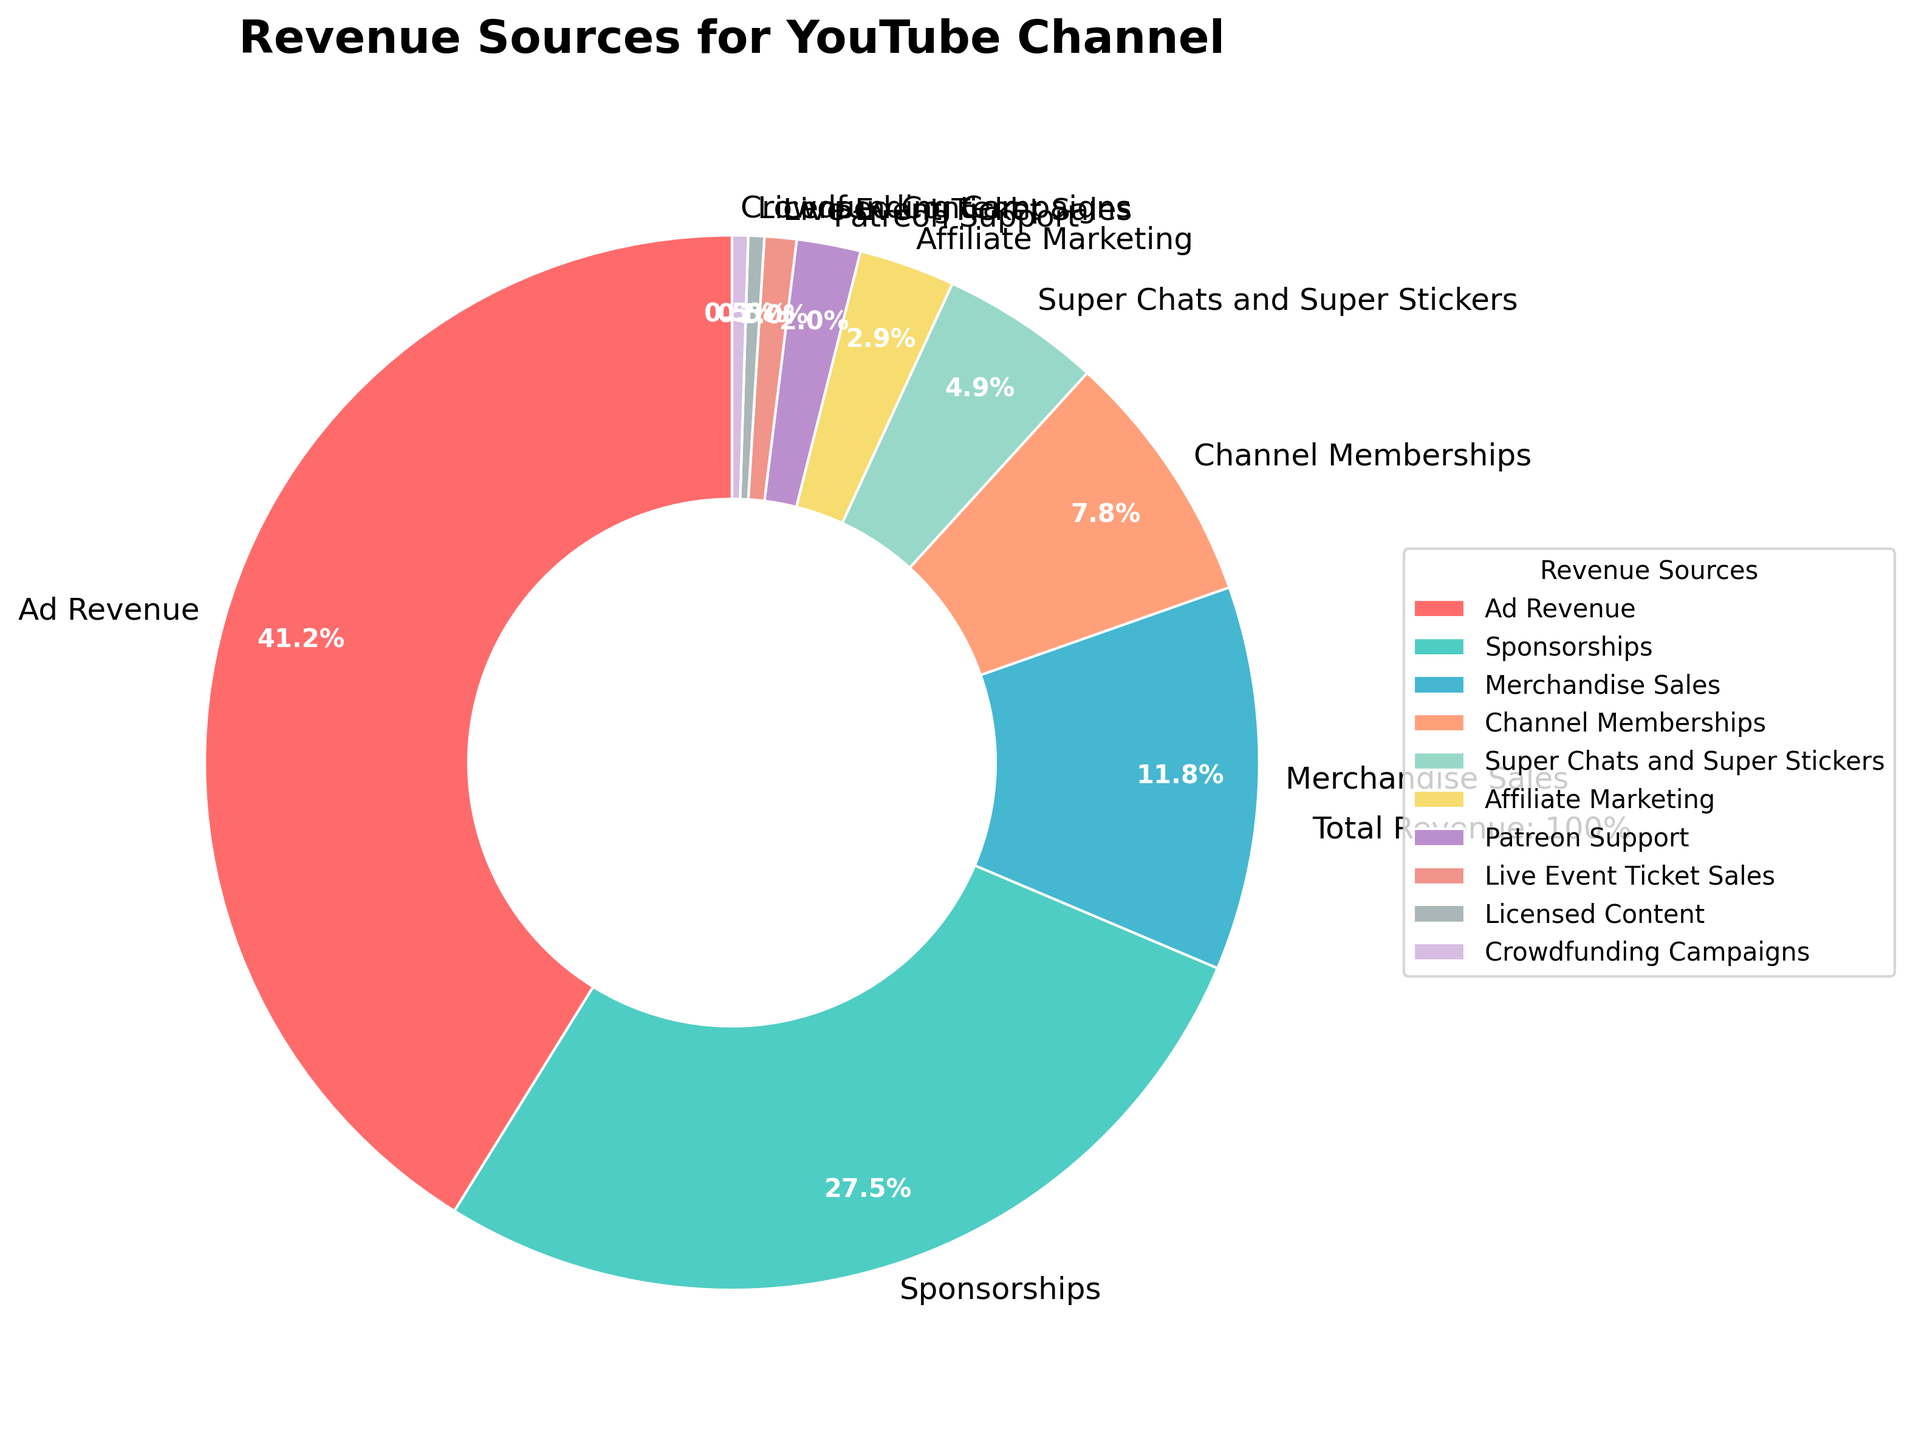Which revenue source contributes the most to the total revenue? By examining the pie chart, we can observe that the segment representing Ad Revenue is the largest. This indicates that Ad Revenue contributes the most to the total revenue of the YouTube channel.
Answer: Ad Revenue What percentage of the total revenue comes from Sponsorships and Merchandise Sales combined? From the pie chart, Sponsorships contribute 28% and Merchandise Sales contribute 12%. Adding these together, we get 28% + 12% = 40%.
Answer: 40% How does the revenue from Channel Memberships compare to the revenue from Super Chats and Super Stickers? The pie chart shows that Channel Memberships account for 8% of the revenue, whereas Super Chats and Super Stickers account for 5%. Therefore, Channel Memberships generate more revenue than Super Chats and Super Stickers.
Answer: Channel Memberships generate more Which revenue source contributes the least to the total revenue? Looking at the pie chart, both Licensed Content and Crowdfunding Campaigns appear to be the smallest segments with 0.5% each. Thus, they contribute the least to the total revenue.
Answer: Licensed Content and Crowdfunding Campaigns What is the combined percentage of revenue generated by Affiliate Marketing, Patreon Support, and Live Event Ticket Sales? According to the pie chart, Affiliate Marketing accounts for 3%, Patreon Support for 2%, and Live Event Ticket Sales for 1%. Adding these together results in 3% + 2% + 1% = 6%.
Answer: 6% What percentage of revenue is generated from non-advertising sources? Summing up the percentages of all revenue sources except Ad Revenue (42%), we have: Sponsorships (28%) + Merchandise Sales (12%) + Channel Memberships (8%) + Super Chats and Super Stickers (5%) + Affiliate Marketing (3%) + Patreon Support (2%) + Live Event Ticket Sales (1%) + Licensed Content (0.5%) + Crowdfunding Campaigns (0.5%) = 60%.
Answer: 60% If Ad Revenue and Sponsorships are combined, what percentage of the total revenue do they account for? Ad Revenue contributes 42% and Sponsorships contribute 28%. Adding these together, we get 42% + 28% = 70%.
Answer: 70% What is the visual color of the segment representing Merchandise Sales in the pie chart? Referring to the visual attributes in the pie chart legend, the segment for Merchandise Sales is represented in a light orange color.
Answer: Light orange How does Merchandise Sales revenue compare to Channel Memberships revenue in terms of percentage? The pie chart indicates that Merchandise Sales account for 12% and Channel Memberships account for 8%. Therefore, Merchandise Sales generate 4% more revenue than Channel Memberships.
Answer: 4% more What is the total percentage of revenue sources that individually contribute less than 10%? Summing the percentages from the pie chart of revenue sources that each contribute less than 10%: Channel Memberships (8%), Super Chats and Super Stickers (5%), Affiliate Marketing (3%), Patreon Support (2%), Live Event Ticket Sales (1%), Licensed Content (0.5%), and Crowdfunding Campaigns (0.5%) gives 8% + 5% + 3% + 2% + 1% + 0.5% + 0.5% = 20%.
Answer: 20% 